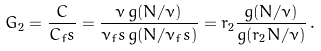<formula> <loc_0><loc_0><loc_500><loc_500>G _ { 2 } = \frac { C } { C _ { f } s } = \frac { \nu \, g ( N / \nu ) } { \nu _ { f } s \, g ( N / \nu _ { f } s ) } = r _ { 2 } \frac { g ( N / \nu ) } { g ( r _ { 2 } N / \nu ) } \, .</formula> 